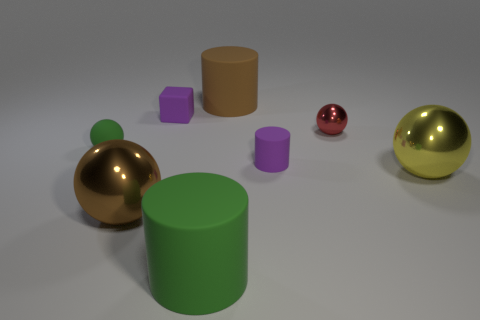There is a matte thing that is the same shape as the yellow shiny thing; what is its color?
Make the answer very short. Green. There is a matte cylinder that is behind the small purple cube; is it the same size as the red metallic sphere that is in front of the tiny cube?
Provide a short and direct response. No. Are there any small gray metal objects of the same shape as the yellow object?
Make the answer very short. No. Are there the same number of purple things behind the big green matte object and small metallic cylinders?
Your answer should be very brief. No. Is the size of the green matte sphere the same as the brown thing that is in front of the purple cylinder?
Offer a very short reply. No. What number of large cylinders have the same material as the yellow sphere?
Make the answer very short. 0. Do the yellow thing and the purple cylinder have the same size?
Provide a succinct answer. No. Is there anything else that has the same color as the cube?
Keep it short and to the point. Yes. There is a metallic thing that is both left of the yellow thing and behind the big brown sphere; what is its shape?
Offer a very short reply. Sphere. How big is the purple thing that is behind the red object?
Provide a succinct answer. Small. 